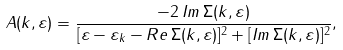Convert formula to latex. <formula><loc_0><loc_0><loc_500><loc_500>A ( k , \varepsilon ) = \frac { - 2 \, I m \, \Sigma ( k , \varepsilon ) } { [ \varepsilon - \varepsilon _ { k } - R e \, \Sigma ( k , \varepsilon ) ] ^ { 2 } + [ I m \, \Sigma ( k , \varepsilon ) ] ^ { 2 } } ,</formula> 